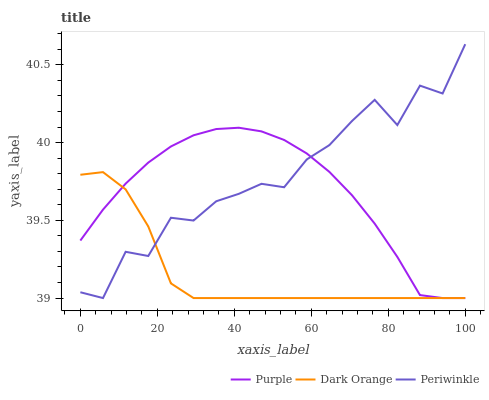Does Dark Orange have the minimum area under the curve?
Answer yes or no. Yes. Does Periwinkle have the maximum area under the curve?
Answer yes or no. Yes. Does Periwinkle have the minimum area under the curve?
Answer yes or no. No. Does Dark Orange have the maximum area under the curve?
Answer yes or no. No. Is Purple the smoothest?
Answer yes or no. Yes. Is Periwinkle the roughest?
Answer yes or no. Yes. Is Dark Orange the smoothest?
Answer yes or no. No. Is Dark Orange the roughest?
Answer yes or no. No. Does Purple have the lowest value?
Answer yes or no. Yes. Does Periwinkle have the highest value?
Answer yes or no. Yes. Does Dark Orange have the highest value?
Answer yes or no. No. Does Periwinkle intersect Dark Orange?
Answer yes or no. Yes. Is Periwinkle less than Dark Orange?
Answer yes or no. No. Is Periwinkle greater than Dark Orange?
Answer yes or no. No. 